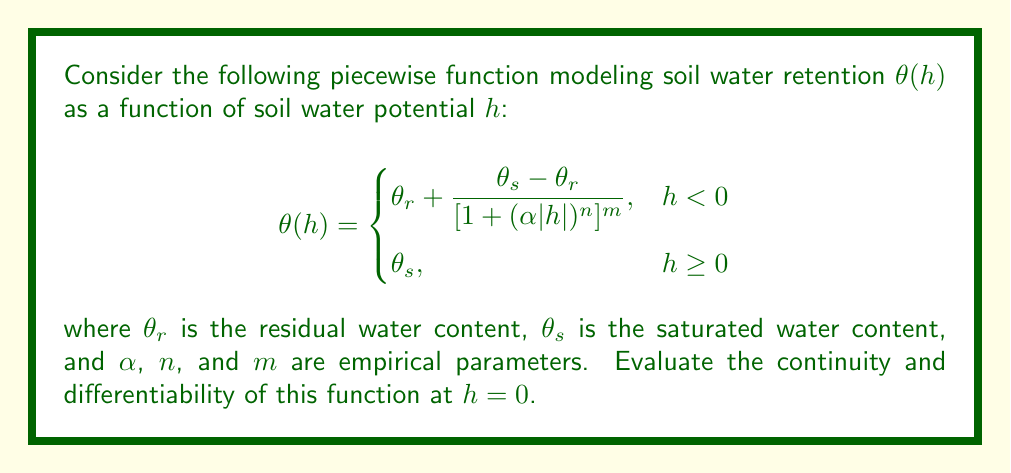Help me with this question. To evaluate the continuity and differentiability of the function $\theta(h)$ at $h = 0$, we need to examine the left-hand and right-hand limits, as well as the left-hand and right-hand derivatives.

1. Continuity:
   To be continuous at $h = 0$, the left-hand limit, right-hand limit, and the function value at $h = 0$ must all be equal.

   Right-hand limit: $\lim_{h \to 0^+} \theta(h) = \theta_s$

   Left-hand limit: 
   $$\lim_{h \to 0^-} \theta(h) = \lim_{h \to 0^-} \left(\theta_r + \frac{\theta_s - \theta_r}{[1 + (\alpha|h|)^n]^m}\right)$$
   As $h$ approaches 0 from the left, $|h|$ approaches 0, so:
   $$\lim_{h \to 0^-} \theta(h) = \theta_r + (\theta_s - \theta_r) = \theta_s$$

   Function value at $h = 0$: $\theta(0) = \theta_s$

   Since all three values are equal to $\theta_s$, the function is continuous at $h = 0$.

2. Differentiability:
   For the function to be differentiable at $h = 0$, the left-hand and right-hand derivatives must exist and be equal.

   Right-hand derivative:
   $$\lim_{h \to 0^+} \frac{\theta(h) - \theta(0)}{h} = \lim_{h \to 0^+} \frac{\theta_s - \theta_s}{h} = 0$$

   Left-hand derivative:
   $$\begin{aligned}
   \lim_{h \to 0^-} \frac{\theta(h) - \theta(0)}{h} &= \lim_{h \to 0^-} \frac{\theta_r + \frac{\theta_s - \theta_r}{[1 + (\alpha|h|)^n]^m} - \theta_s}{h} \\
   &= \lim_{h \to 0^-} \frac{(\theta_s - \theta_r)(1 - [1 + (\alpha|h|)^n]^m)}{h[1 + (\alpha|h|)^n]^m} \\
   &= (\theta_s - \theta_r) \cdot \lim_{h \to 0^-} \frac{1 - [1 + (\alpha|h|)^n]^m}{h[1 + (\alpha|h|)^n]^m}
   \end{aligned}$$

   This limit does not evaluate to 0 unless $m = 0$ (which is not typically the case in soil water retention models). Therefore, the left-hand derivative is not equal to the right-hand derivative, and the function is not differentiable at $h = 0$.
Answer: The function $\theta(h)$ is continuous at $h = 0$ but not differentiable at $h = 0$. 